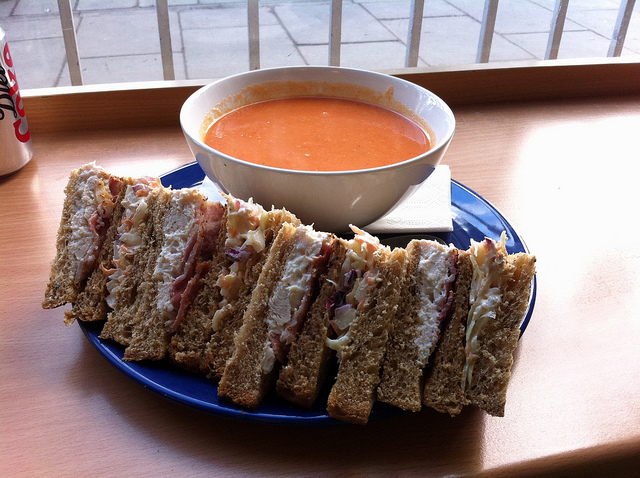<image>What kind of food is this? I can't determine the exact kind of food, but it can be a combination of sandwich and soup. What kind of food is this? I am not sure what kind of food this is. It could be a sandwich or soup, or a combination of both. 